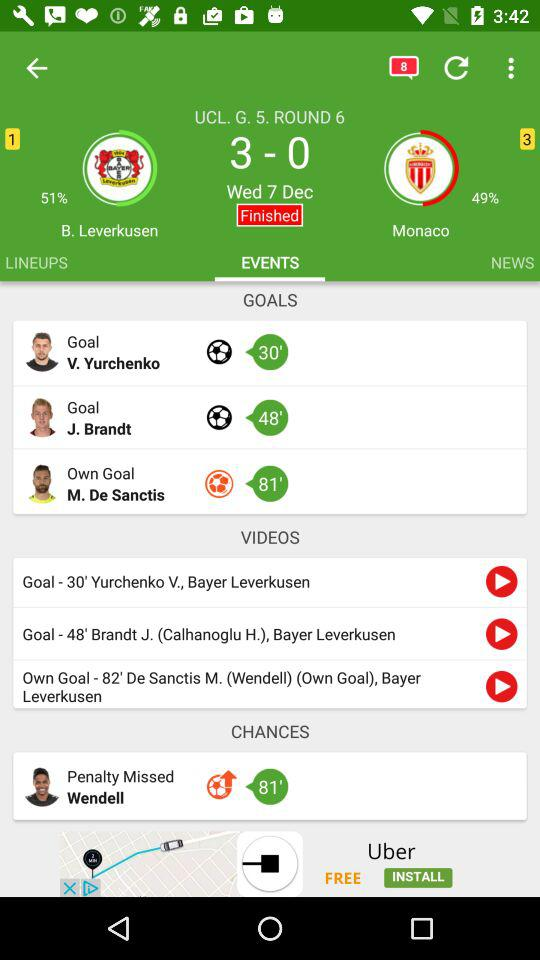How many more goals did Leverkusen score than Monaco?
Answer the question using a single word or phrase. 3 